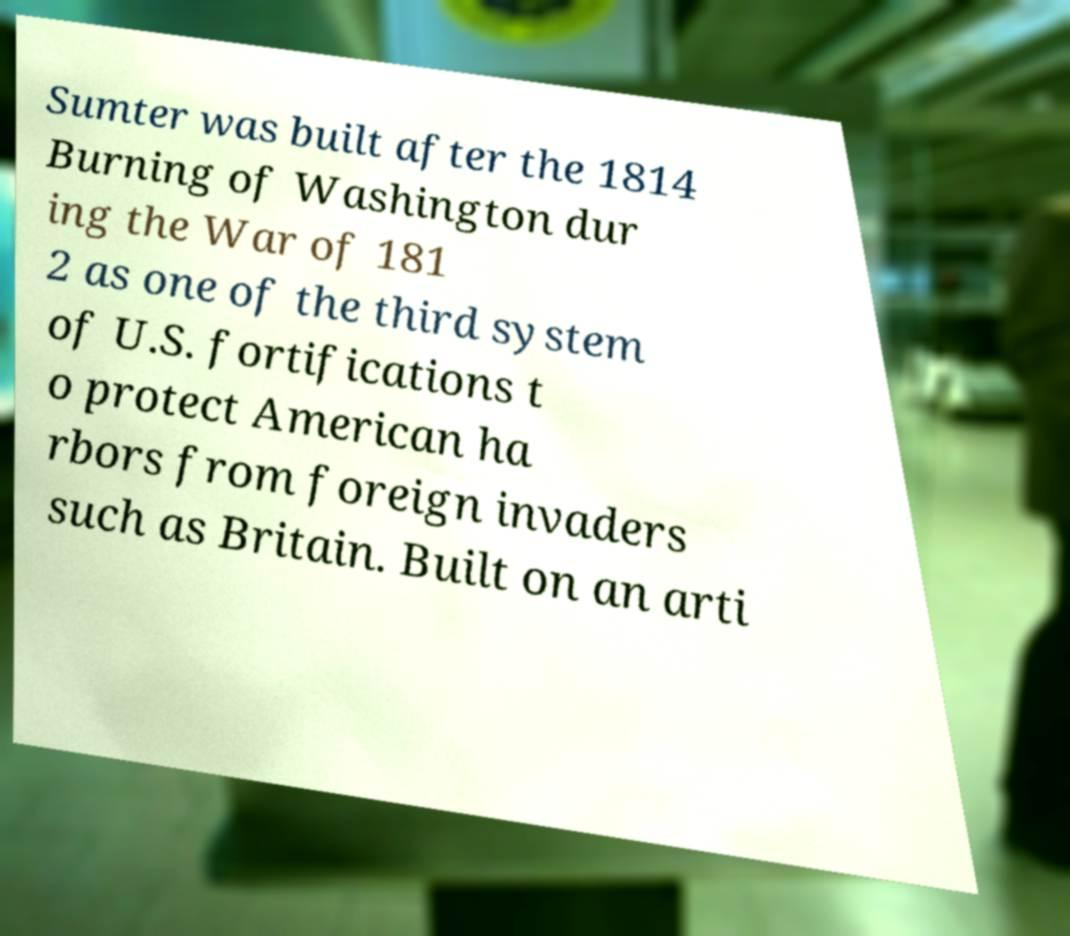Could you assist in decoding the text presented in this image and type it out clearly? Sumter was built after the 1814 Burning of Washington dur ing the War of 181 2 as one of the third system of U.S. fortifications t o protect American ha rbors from foreign invaders such as Britain. Built on an arti 